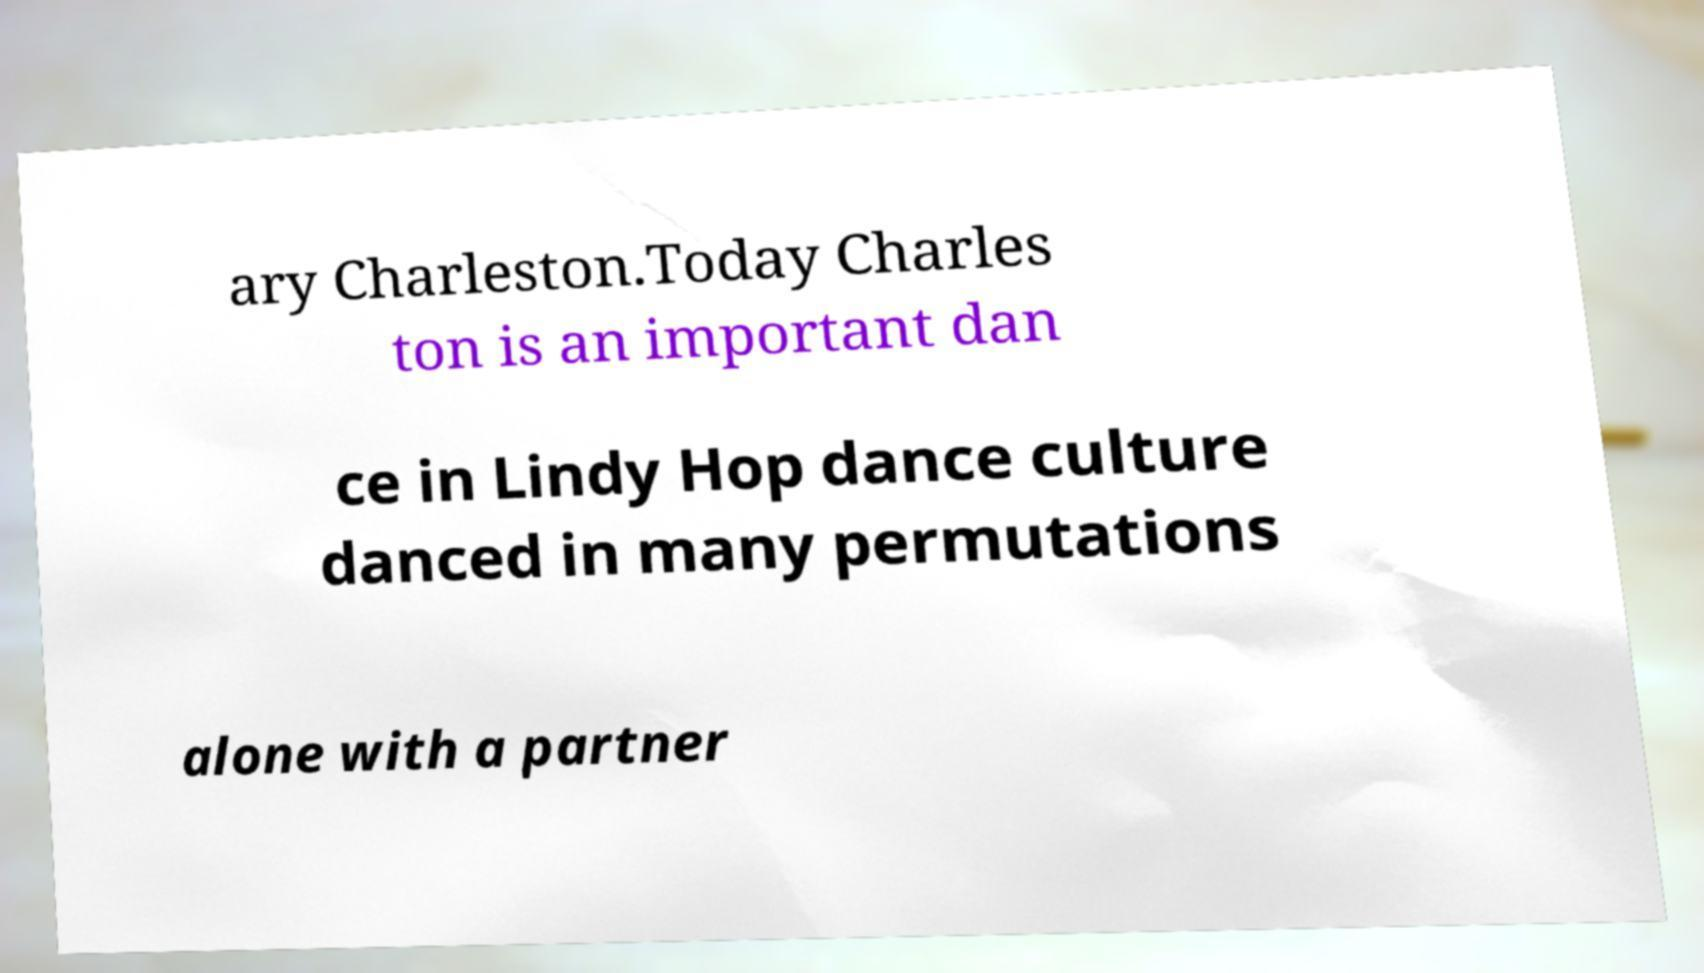Can you accurately transcribe the text from the provided image for me? ary Charleston.Today Charles ton is an important dan ce in Lindy Hop dance culture danced in many permutations alone with a partner 